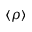<formula> <loc_0><loc_0><loc_500><loc_500>\langle \rho \rangle</formula> 